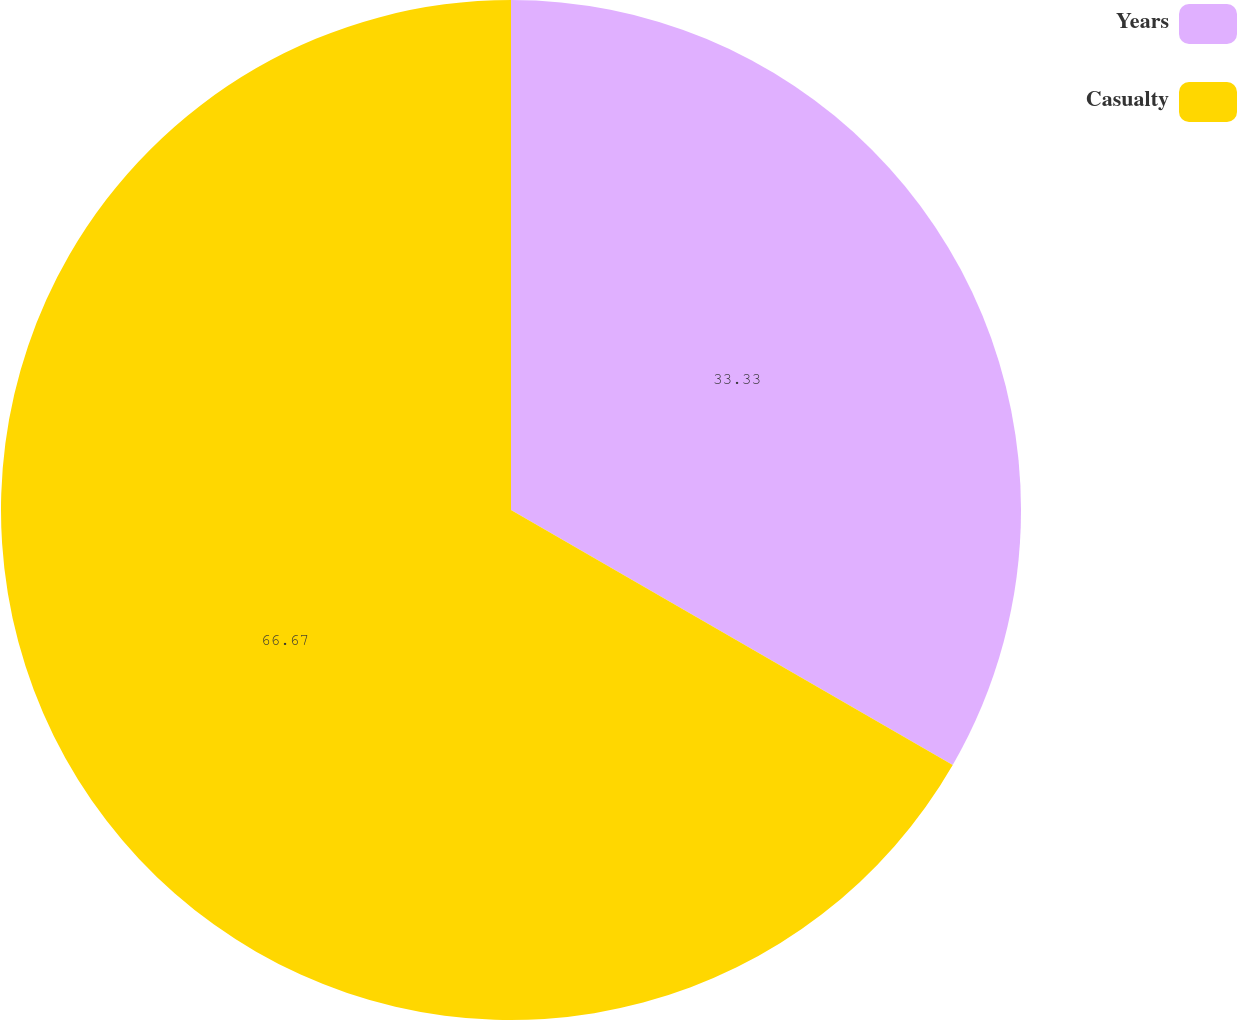Convert chart. <chart><loc_0><loc_0><loc_500><loc_500><pie_chart><fcel>Years<fcel>Casualty<nl><fcel>33.33%<fcel>66.67%<nl></chart> 